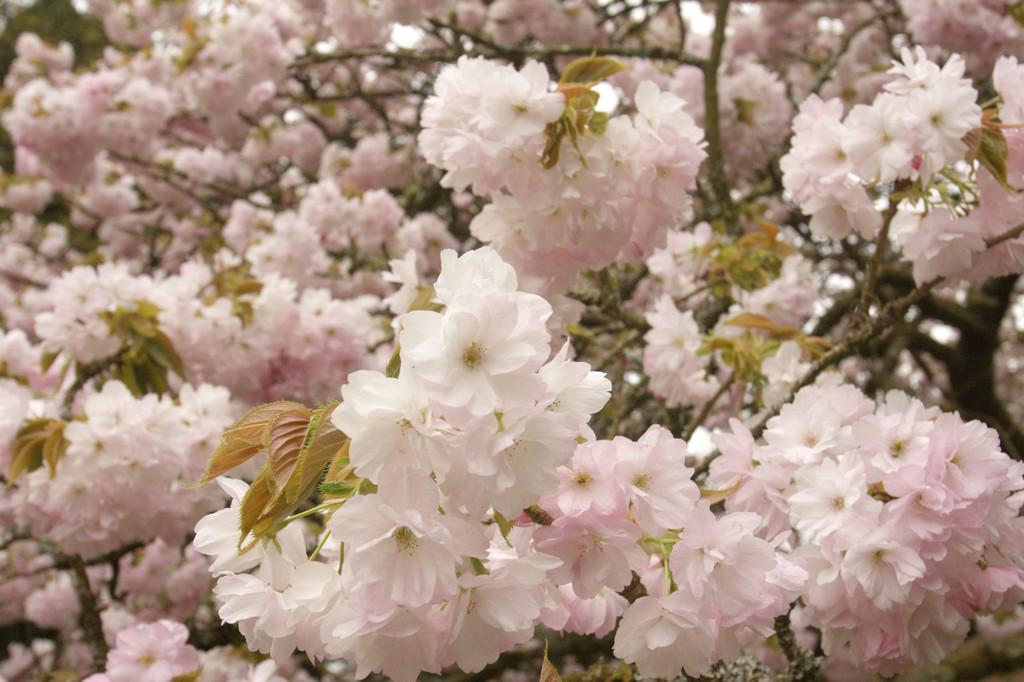What type of plant life is visible in the image? There are flowers, leaves, and branches in the image. Can you describe the specific parts of the plants that are visible? The flowers, leaves, and branches are all visible in the image. What type of insect can be seen crawling on the leaves in the image? There are no insects visible in the image; only flowers, leaves, and branches are present. 